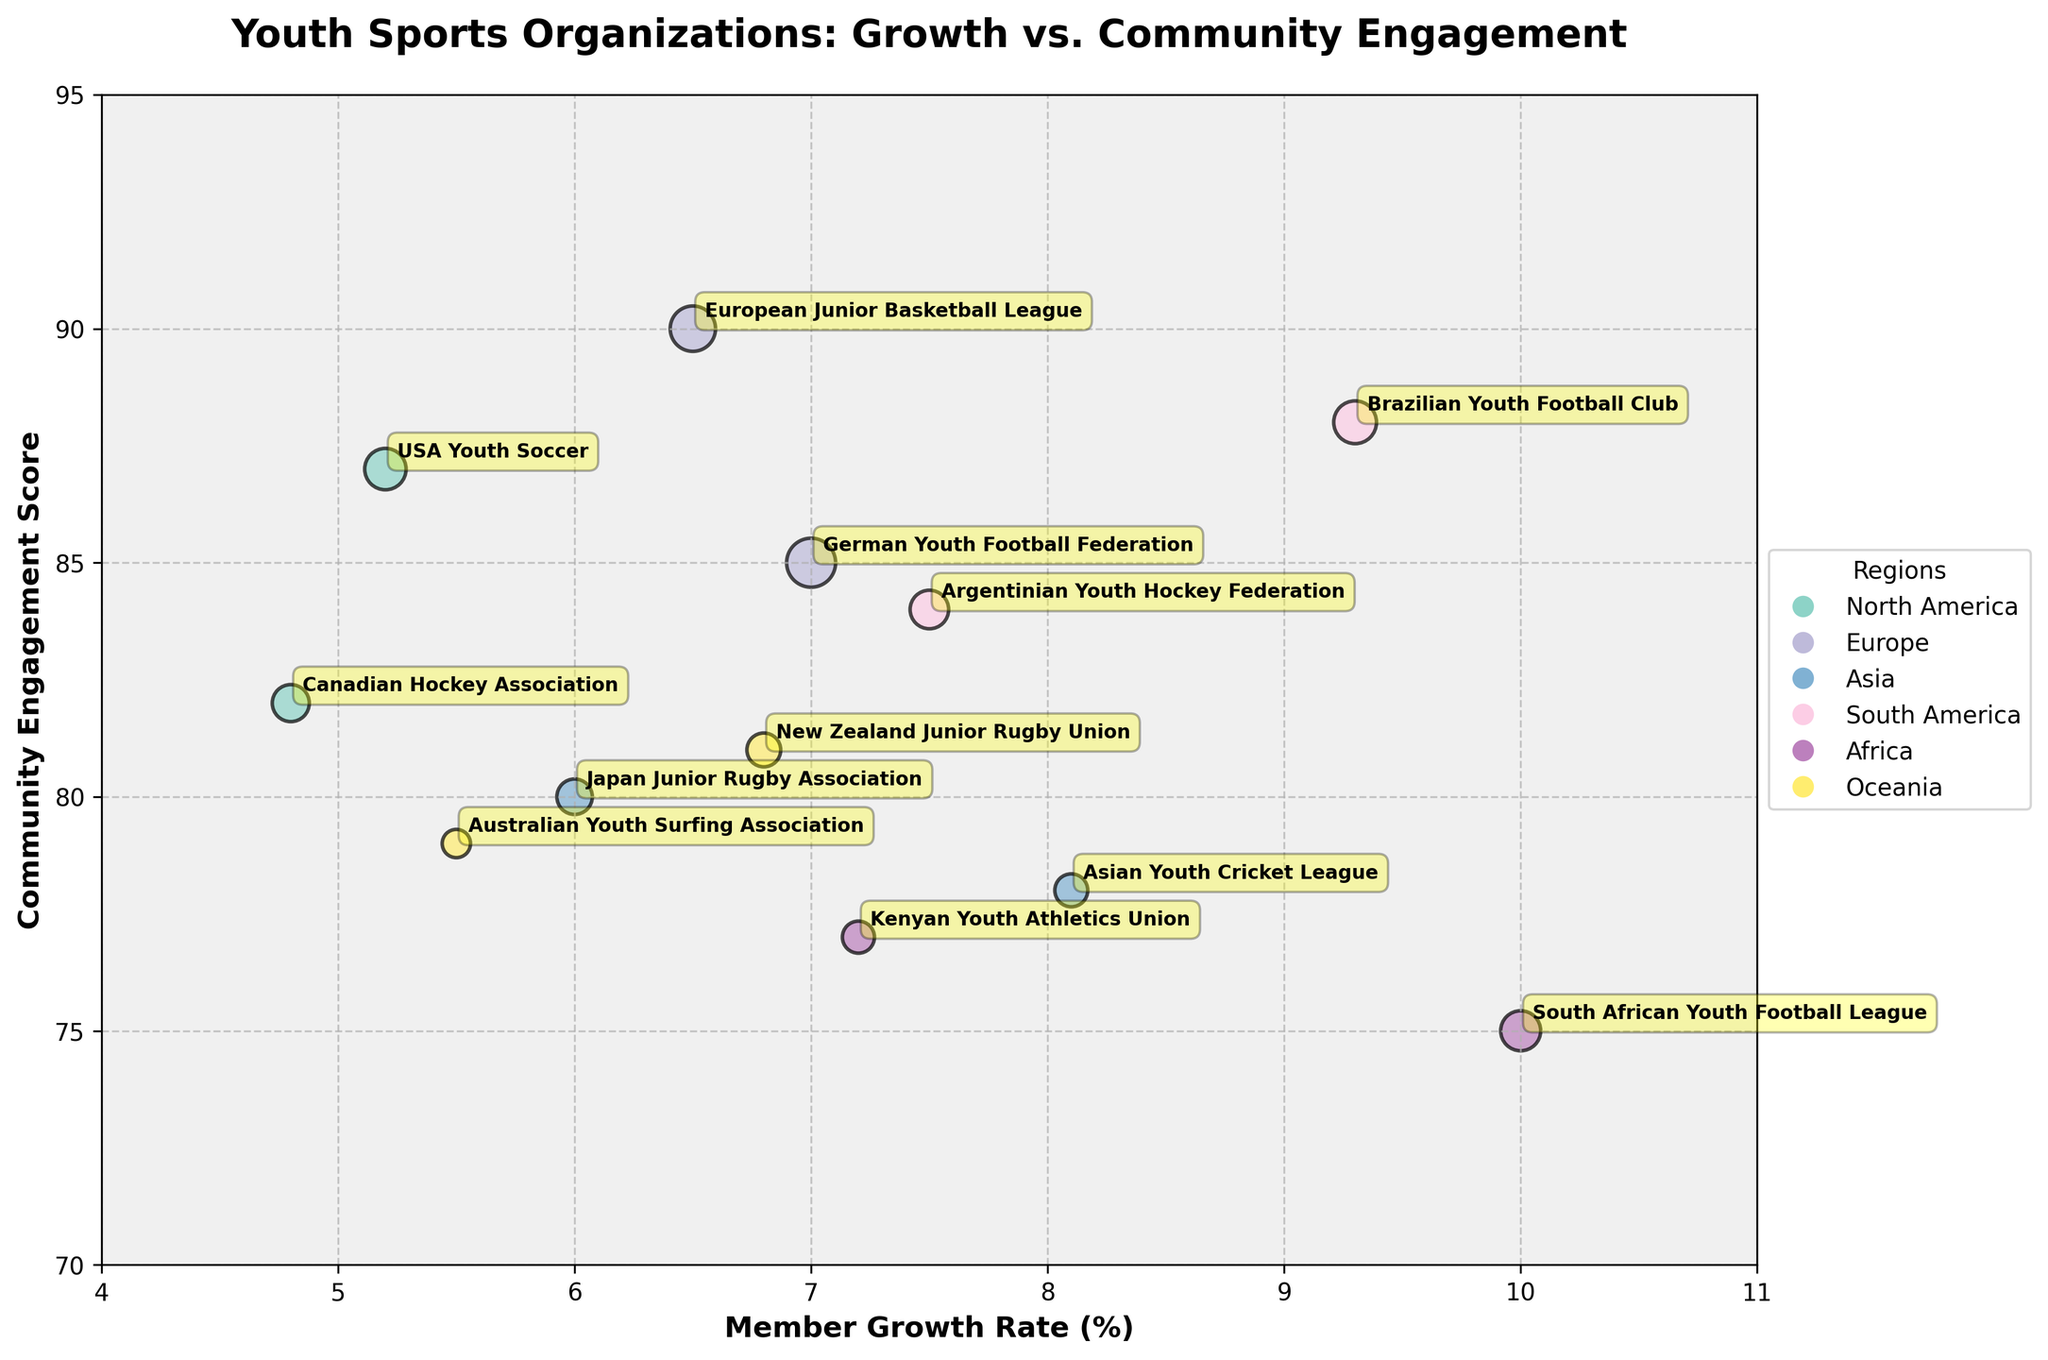What's the title of the figure? The title of the figure is usually found at the top of the chart in a larger or bold font. In this case, the title "Youth Sports Organizations: Growth vs. Community Engagement" is clearly stated at the top.
Answer: Youth Sports Organizations: Growth vs. Community Engagement What are the labels for the axes? The labels for the axes usually describe the variables being plotted. In this figure, the x-axis is labeled "Member Growth Rate (%)" and the y-axis is labeled "Community Engagement Score".
Answer: Member Growth Rate (%), Community Engagement Score How many regions are represented in the figure? Different regions are usually indicated by different colors in the bubbles. According to the legend and the number of different symbols in the legend, there are 6 regions represented.
Answer: 6 Which Youth Organization has the highest Member Growth Rate (%) and what is it? To find the highest Member Growth Rate, look for the rightmost bubble on the x-axis. The Brazilian Youth Football Club is positioned at about 9.3%, which is the highest rate.
Answer: Brazilian Youth Football Club, 9.3% What is the average Age of teams with a Community Engagement Score above 80 from Europe? Identify the bubbles representing Europe (by their color/annotation) and check their Community Engagement Scores above 80. The European Junior Basketball League has a score of 90 and an average age of 13, while the German Youth Football Federation has a score of 85 and an average age of 12. Average them: (13 + 12) / 2 = 12.5.
Answer: 12.5 Compare the Member Growth Rates between organizations in North America and Asia. Which region has the higher average Member Growth Rate? Calculate the average Member Growth Rate for each region. North America: (5.2 + 4.8) / 2 = 5.0. Asia: (8.1 + 6.0) / 2 = 7.05. Asia has the higher average Member Growth Rate.
Answer: Asia Which region has the organization with the lowest Community Engagement Score and what is that score? Look for the lowest point on the y-axis across all bubbles. This is the South African Youth Football League in Africa with a score of 75.
Answer: Africa, 75 Which youth organization has the largest bubble, indicating the greatest number of teams, and how many teams does it have? The largest bubble will visually stand out due to its size. The German Youth Football Federation has the largest bubble with 210 teams.
Answer: German Youth Football Federation, 210 Among the organizations from Oceania, which one has the higher Community Engagement Score? There are two organizations from Oceania. Compare their y-axis positions: the Australian Youth Surfing Association has a score of 79, and the New Zealand Junior Rugby Union has a score of 81. The latter is higher.
Answer: New Zealand Junior Rugby Union 